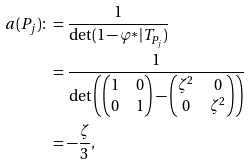Convert formula to latex. <formula><loc_0><loc_0><loc_500><loc_500>a ( P _ { j } ) \colon & = \frac { 1 } { \det ( 1 - \varphi ^ { \ast } | T _ { P _ { j } } ) } \\ & = \frac { 1 } { \det \left ( \begin{pmatrix} 1 & 0 \\ 0 & 1 \end{pmatrix} - \begin{pmatrix} \zeta ^ { 2 } & 0 \\ 0 & \zeta ^ { 2 } \end{pmatrix} \right ) } \\ & = - \frac { \zeta } { 3 } ,</formula> 